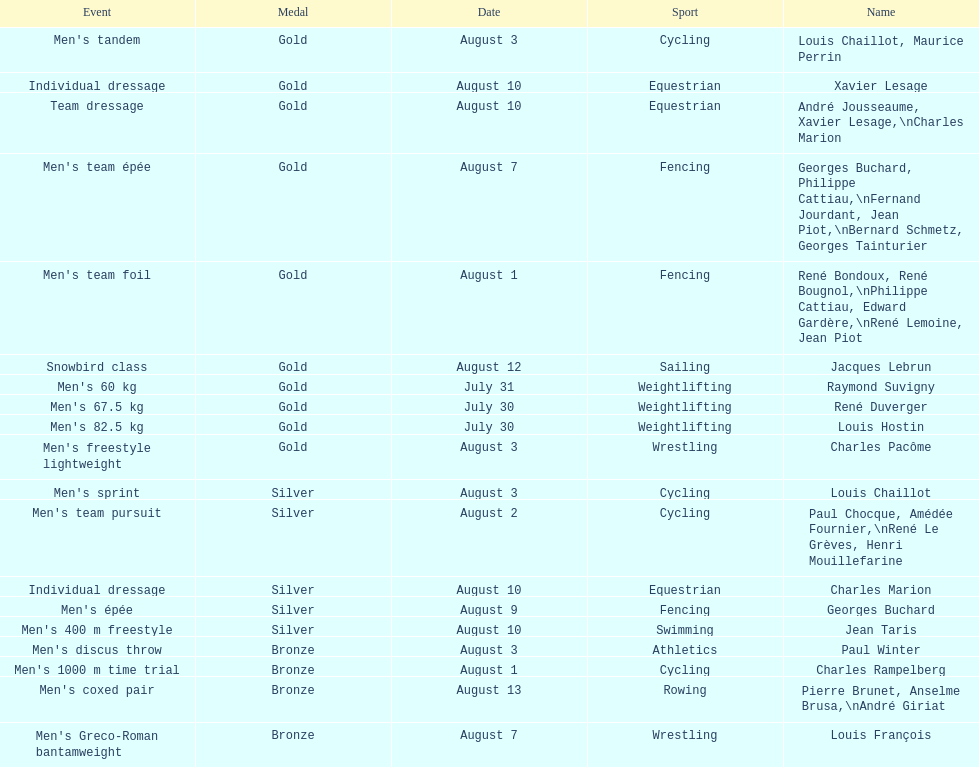Which event won the most medals? Cycling. 